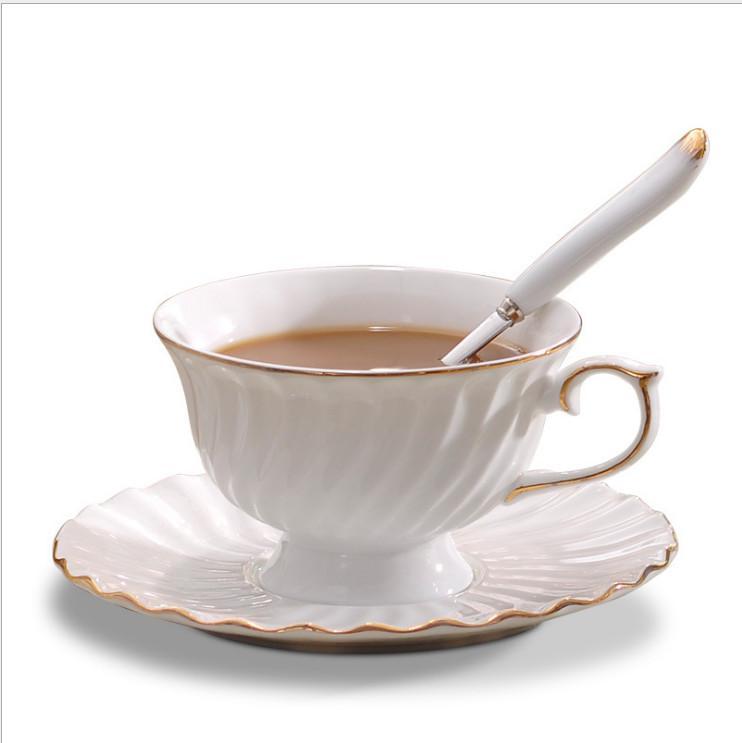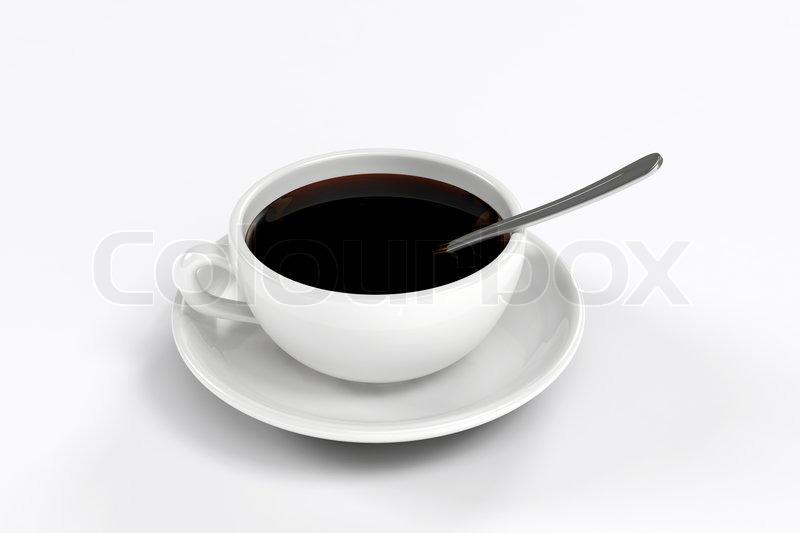The first image is the image on the left, the second image is the image on the right. Examine the images to the left and right. Is the description "There is a spoon in at least one teacup" accurate? Answer yes or no. Yes. The first image is the image on the left, the second image is the image on the right. Evaluate the accuracy of this statement regarding the images: "The handle of a utensil sticks out of a cup of coffee in at least one image.". Is it true? Answer yes or no. Yes. 